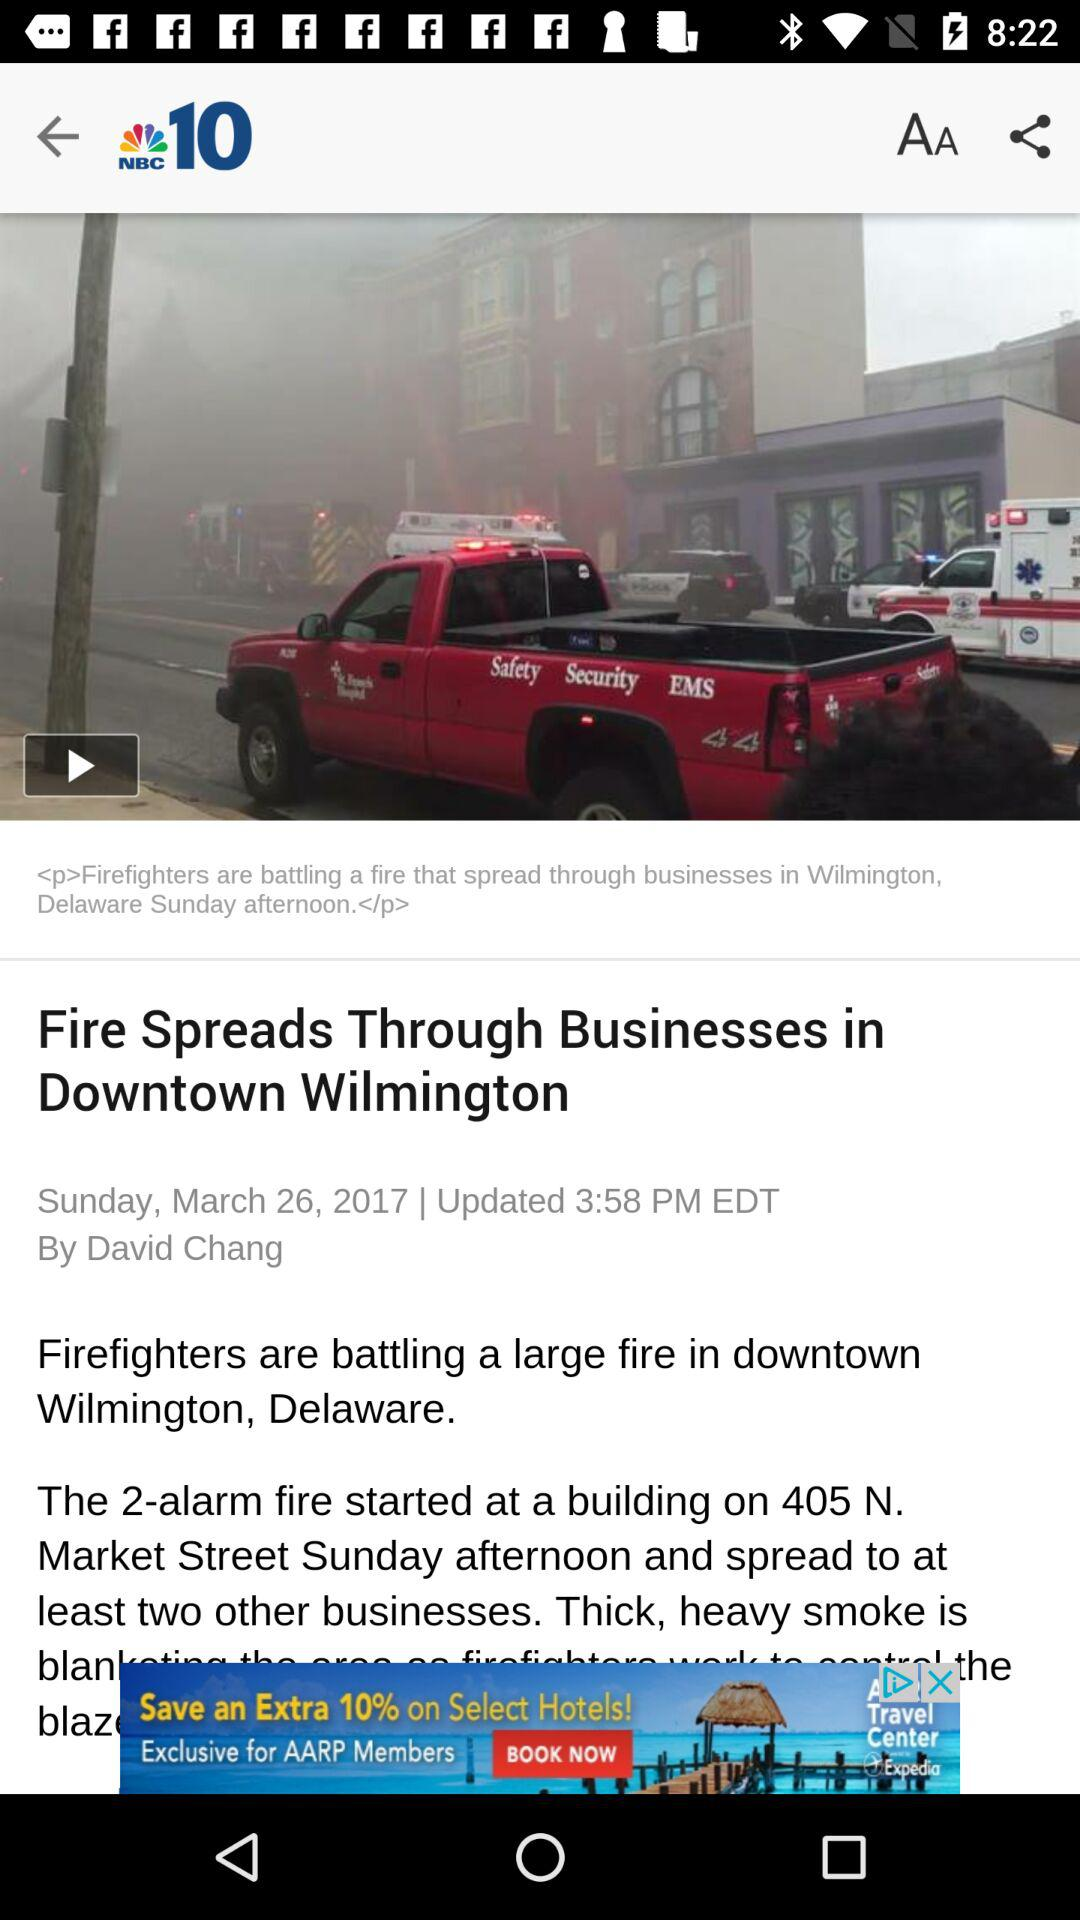What is the update timing? The update time is 3:58 PM EDT. 